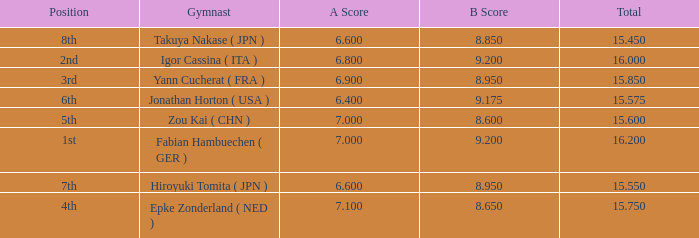What was the total rating that had a score higher than 7 and a b score smaller than 8.65? None. 